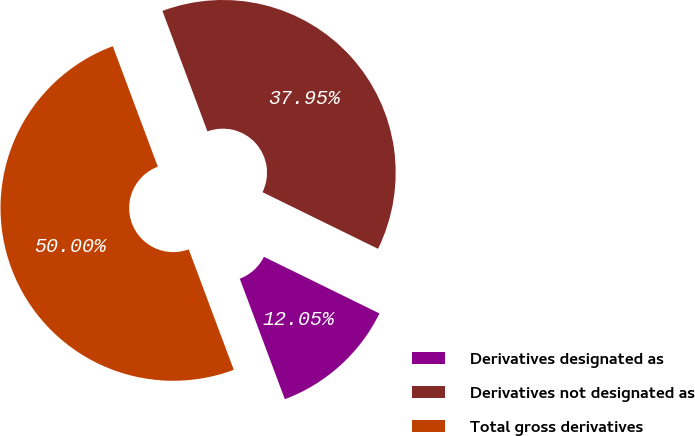Convert chart to OTSL. <chart><loc_0><loc_0><loc_500><loc_500><pie_chart><fcel>Derivatives designated as<fcel>Derivatives not designated as<fcel>Total gross derivatives<nl><fcel>12.05%<fcel>37.95%<fcel>50.0%<nl></chart> 